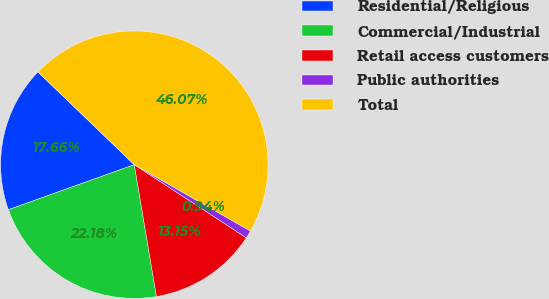<chart> <loc_0><loc_0><loc_500><loc_500><pie_chart><fcel>Residential/Religious<fcel>Commercial/Industrial<fcel>Retail access customers<fcel>Public authorities<fcel>Total<nl><fcel>17.66%<fcel>22.18%<fcel>13.15%<fcel>0.94%<fcel>46.07%<nl></chart> 